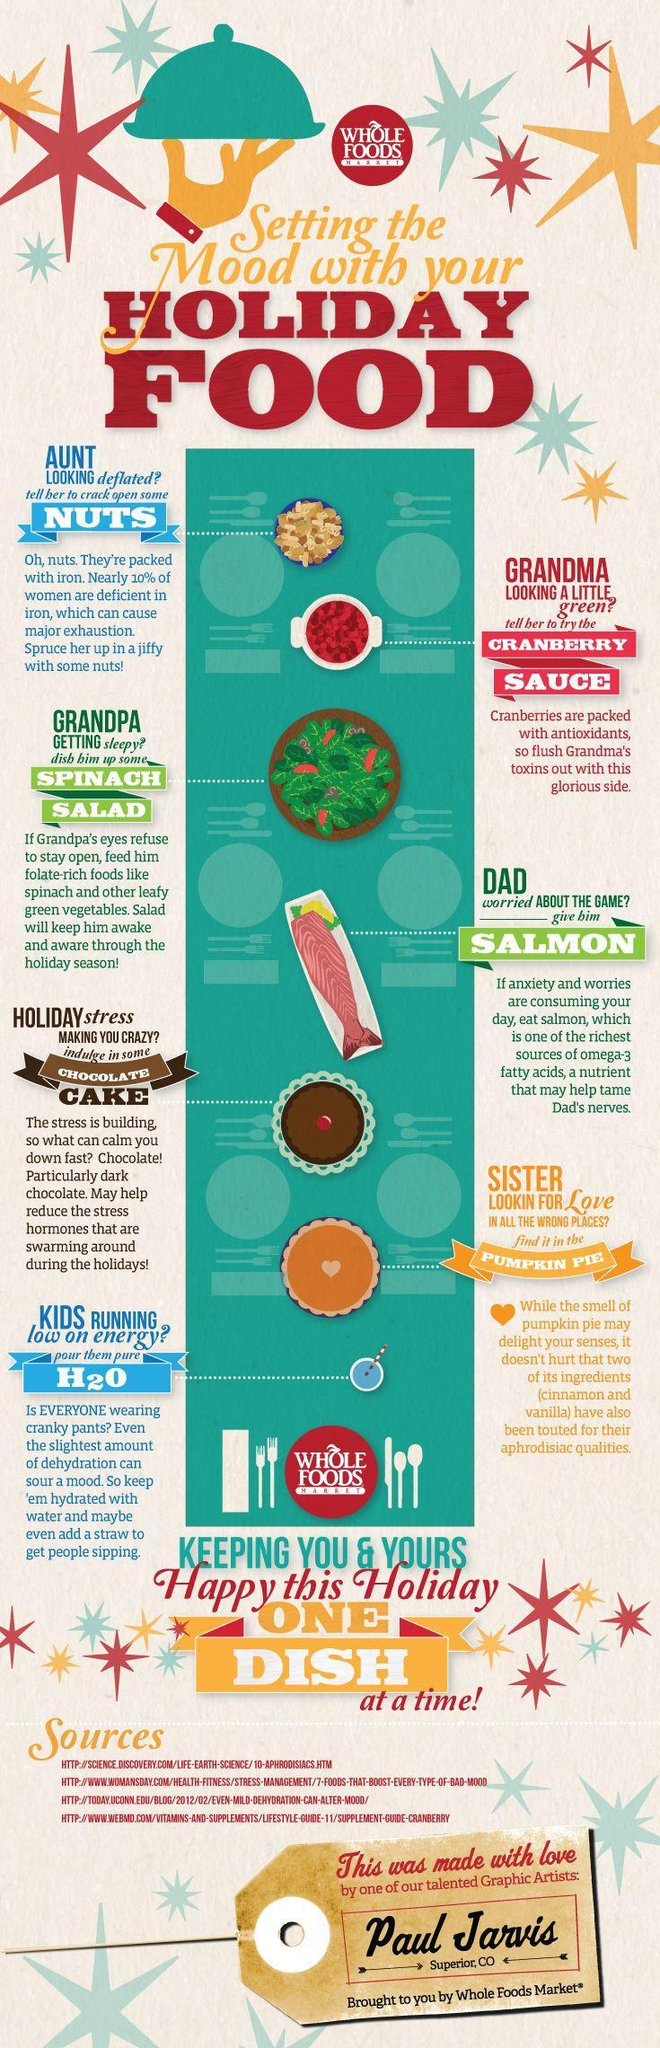Which dishes are denoted by the green color?
Answer the question with a short phrase. Spinach Salad, Salmon How many holiday foods are listed in blue color? 2 To whom should the Cranberry Sauce be served, Aunt, Grandma, or Grandpa? Grandma Which dish can be served for sisters, chocolate cake, pumpkin pie, or H2O ? pumpkin pie 